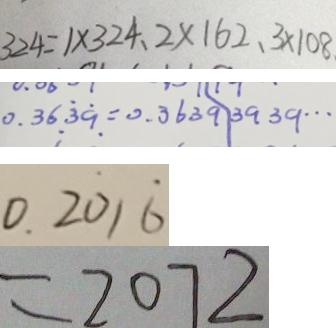Convert formula to latex. <formula><loc_0><loc_0><loc_500><loc_500>3 2 4 = 1 \times 3 2 4 . 2 \times 1 6 2 . 3 \times 1 0 8 . 
 0 . 3 6 \dot { 3 } \dot { 9 } = 0 . 3 6 3 9 \vert 3 9 3 9 \cdots 
 0 . 2 \dot { 0 } 1 \dot { 6 } 
 = 2 0 7 2</formula> 